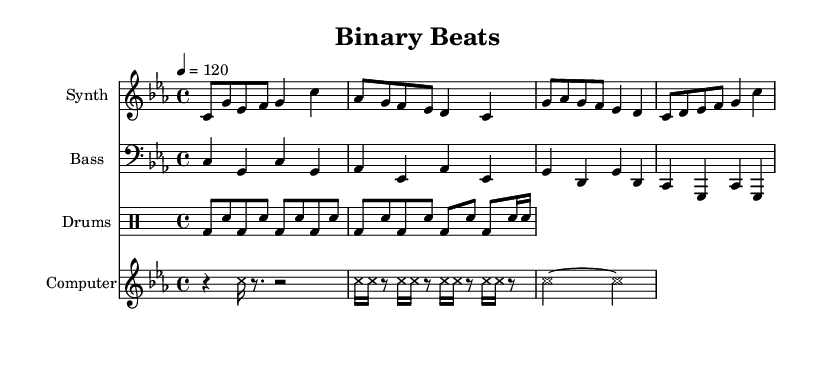What is the key signature of this music? The key signature indicates C minor, as denoted by three flats: B♭, E♭, and A♭.
Answer: C minor What is the time signature of this music? The time signature appears as 4/4, which indicates four beats per measure, with the quarter note receiving one beat.
Answer: 4/4 What is the tempo marking for this piece? The tempo is set to 120 beats per minute, indicated by the marking "4 = 120" in the score.
Answer: 120 How many measures are in the synth section? The synth section contains four measures, evidenced by the grouping of notes and the use of bar lines that separate the measures.
Answer: 4 What is the rhythm pattern of the drums? The drum part alternates between kick drum (bd) and snare drum (sn) in an eighth note pattern, with an added sixteenth note at the end of the second line.
Answer: alternating What instrument is associated with the computer sounds? The computer sounds are written in a staff labeled "Computer," which indicates that they are produced digitally, incorporating glitchy rhythmic elements.
Answer: Computer How do the computer sounds contribute to the glitch-hop style? The computer sounds use rests and a rhythmic pattern of repeated notes, simulating electronic "errors" and keyboard clicks, which are characteristic of glitch-hop.
Answer: electronic sounds 